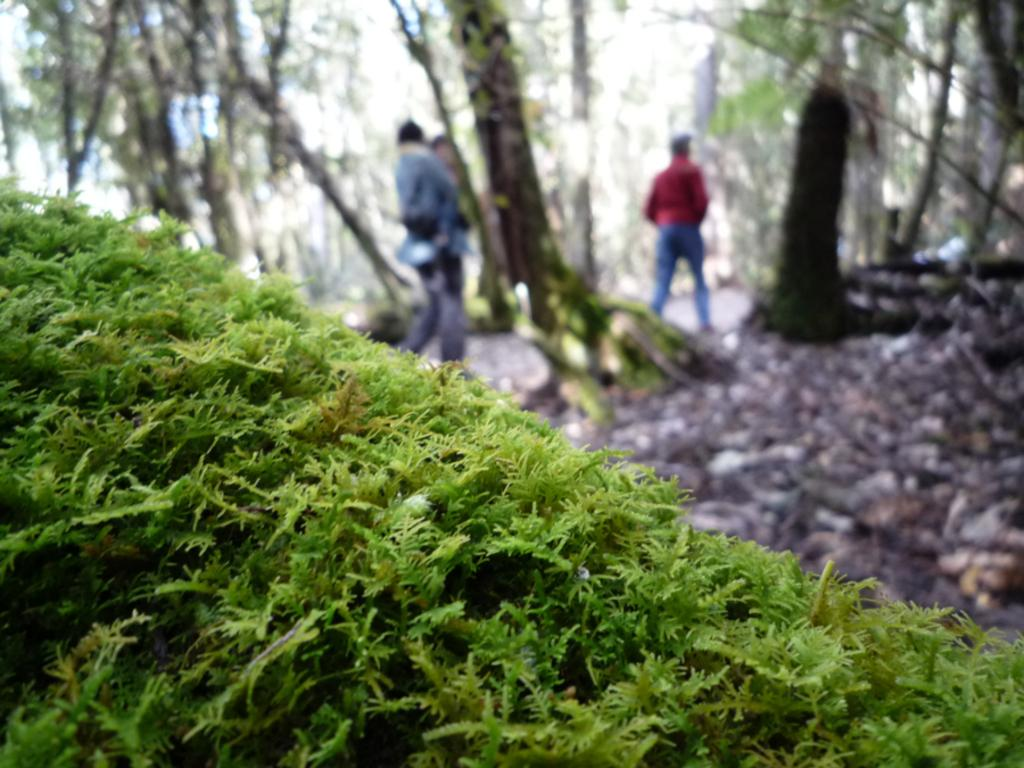What type of vegetation is at the bottom of the image? There is moss at the bottom of the image. What can be seen in the center of the image? There are people in the center of the image. What type of natural scenery is visible in the background of the image? There are trees in the background of the image. Where is the kitten playing in the image? There is no kitten present in the image. What type of seafood is visible in the image? There is no seafood, such as clams, present in the image. 